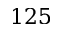<formula> <loc_0><loc_0><loc_500><loc_500>1 2 5</formula> 